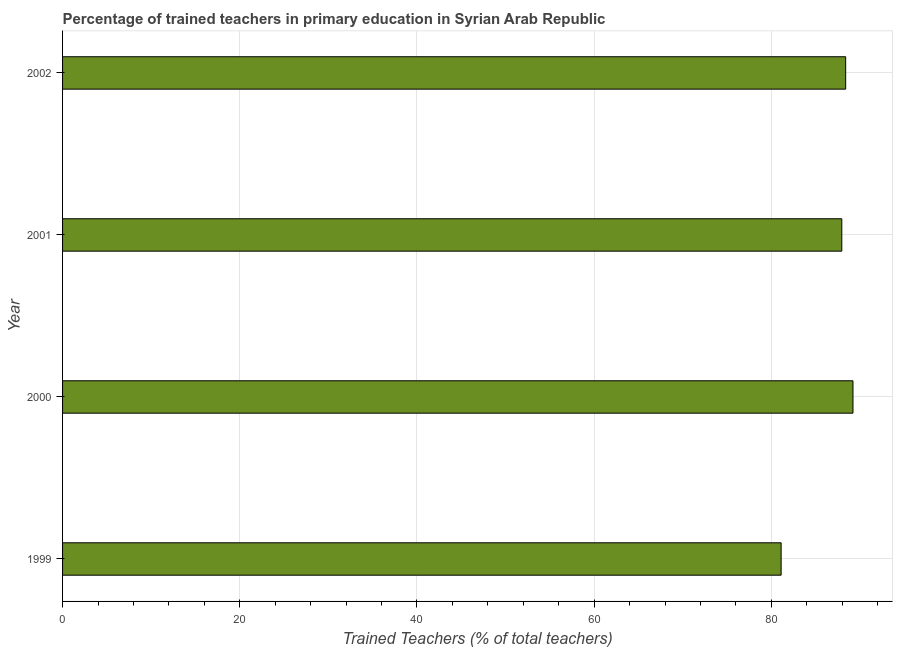Does the graph contain grids?
Provide a short and direct response. Yes. What is the title of the graph?
Give a very brief answer. Percentage of trained teachers in primary education in Syrian Arab Republic. What is the label or title of the X-axis?
Offer a very short reply. Trained Teachers (% of total teachers). What is the label or title of the Y-axis?
Ensure brevity in your answer.  Year. What is the percentage of trained teachers in 2000?
Provide a short and direct response. 89.21. Across all years, what is the maximum percentage of trained teachers?
Ensure brevity in your answer.  89.21. Across all years, what is the minimum percentage of trained teachers?
Keep it short and to the point. 81.1. What is the sum of the percentage of trained teachers?
Your answer should be compact. 346.66. What is the difference between the percentage of trained teachers in 2000 and 2002?
Make the answer very short. 0.82. What is the average percentage of trained teachers per year?
Provide a short and direct response. 86.66. What is the median percentage of trained teachers?
Provide a succinct answer. 88.17. Do a majority of the years between 2002 and 2000 (inclusive) have percentage of trained teachers greater than 16 %?
Your answer should be very brief. Yes. Is the percentage of trained teachers in 1999 less than that in 2002?
Your response must be concise. Yes. Is the difference between the percentage of trained teachers in 1999 and 2002 greater than the difference between any two years?
Offer a very short reply. No. What is the difference between the highest and the second highest percentage of trained teachers?
Provide a succinct answer. 0.82. Is the sum of the percentage of trained teachers in 1999 and 2000 greater than the maximum percentage of trained teachers across all years?
Ensure brevity in your answer.  Yes. What is the difference between the highest and the lowest percentage of trained teachers?
Keep it short and to the point. 8.11. In how many years, is the percentage of trained teachers greater than the average percentage of trained teachers taken over all years?
Make the answer very short. 3. Are all the bars in the graph horizontal?
Give a very brief answer. Yes. What is the difference between two consecutive major ticks on the X-axis?
Provide a short and direct response. 20. Are the values on the major ticks of X-axis written in scientific E-notation?
Offer a terse response. No. What is the Trained Teachers (% of total teachers) in 1999?
Ensure brevity in your answer.  81.1. What is the Trained Teachers (% of total teachers) in 2000?
Ensure brevity in your answer.  89.21. What is the Trained Teachers (% of total teachers) of 2001?
Your response must be concise. 87.95. What is the Trained Teachers (% of total teachers) in 2002?
Ensure brevity in your answer.  88.39. What is the difference between the Trained Teachers (% of total teachers) in 1999 and 2000?
Your answer should be compact. -8.11. What is the difference between the Trained Teachers (% of total teachers) in 1999 and 2001?
Give a very brief answer. -6.85. What is the difference between the Trained Teachers (% of total teachers) in 1999 and 2002?
Your answer should be very brief. -7.29. What is the difference between the Trained Teachers (% of total teachers) in 2000 and 2001?
Keep it short and to the point. 1.26. What is the difference between the Trained Teachers (% of total teachers) in 2000 and 2002?
Provide a succinct answer. 0.82. What is the difference between the Trained Teachers (% of total teachers) in 2001 and 2002?
Make the answer very short. -0.44. What is the ratio of the Trained Teachers (% of total teachers) in 1999 to that in 2000?
Your answer should be very brief. 0.91. What is the ratio of the Trained Teachers (% of total teachers) in 1999 to that in 2001?
Your answer should be compact. 0.92. What is the ratio of the Trained Teachers (% of total teachers) in 1999 to that in 2002?
Your answer should be very brief. 0.92. What is the ratio of the Trained Teachers (% of total teachers) in 2000 to that in 2001?
Give a very brief answer. 1.01. What is the ratio of the Trained Teachers (% of total teachers) in 2000 to that in 2002?
Ensure brevity in your answer.  1.01. 